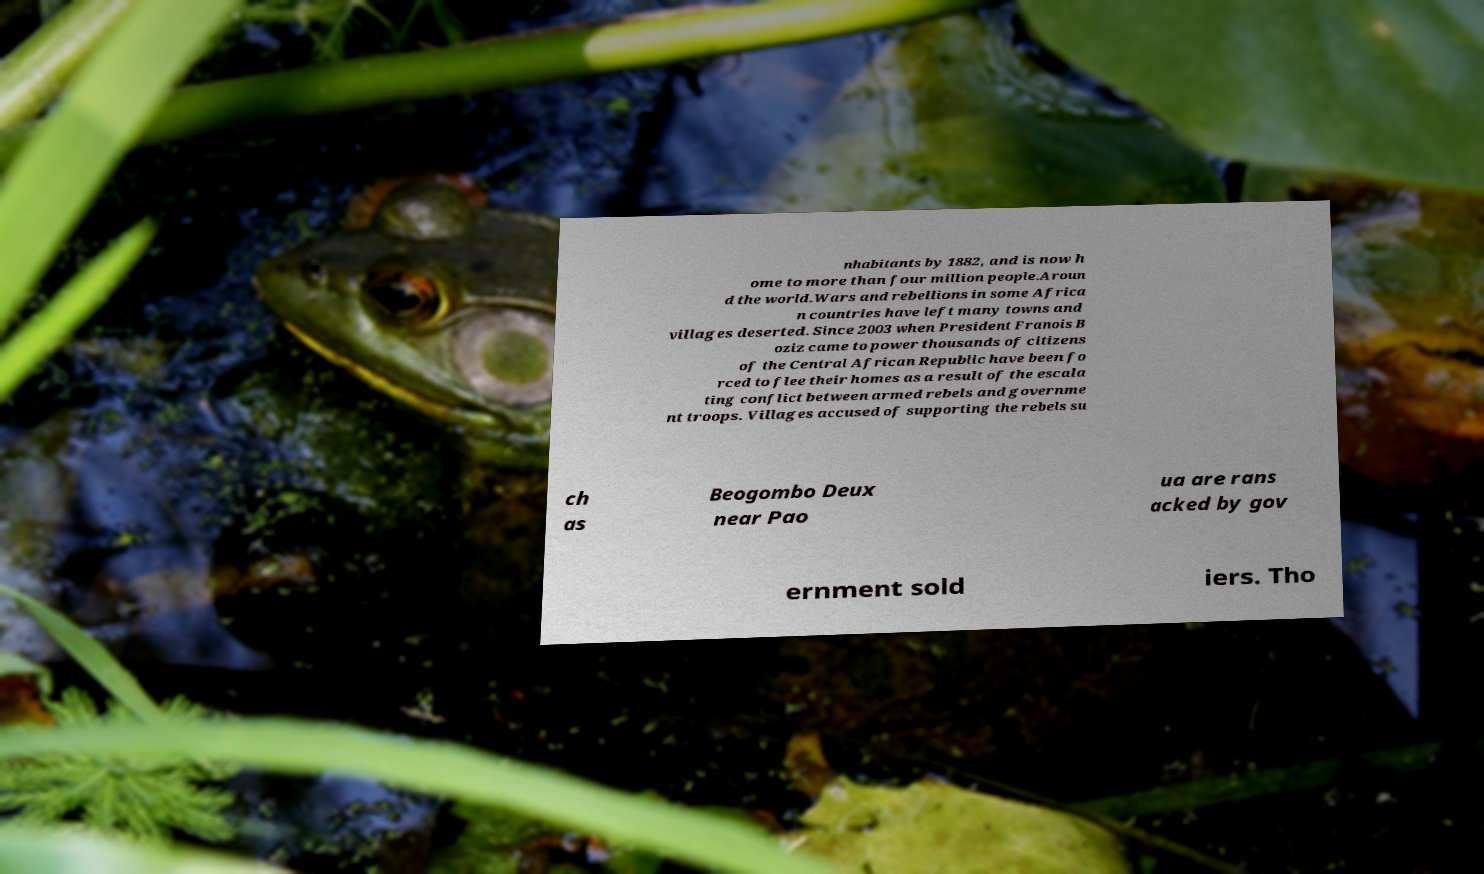Please identify and transcribe the text found in this image. nhabitants by 1882, and is now h ome to more than four million people.Aroun d the world.Wars and rebellions in some Africa n countries have left many towns and villages deserted. Since 2003 when President Franois B oziz came to power thousands of citizens of the Central African Republic have been fo rced to flee their homes as a result of the escala ting conflict between armed rebels and governme nt troops. Villages accused of supporting the rebels su ch as Beogombo Deux near Pao ua are rans acked by gov ernment sold iers. Tho 